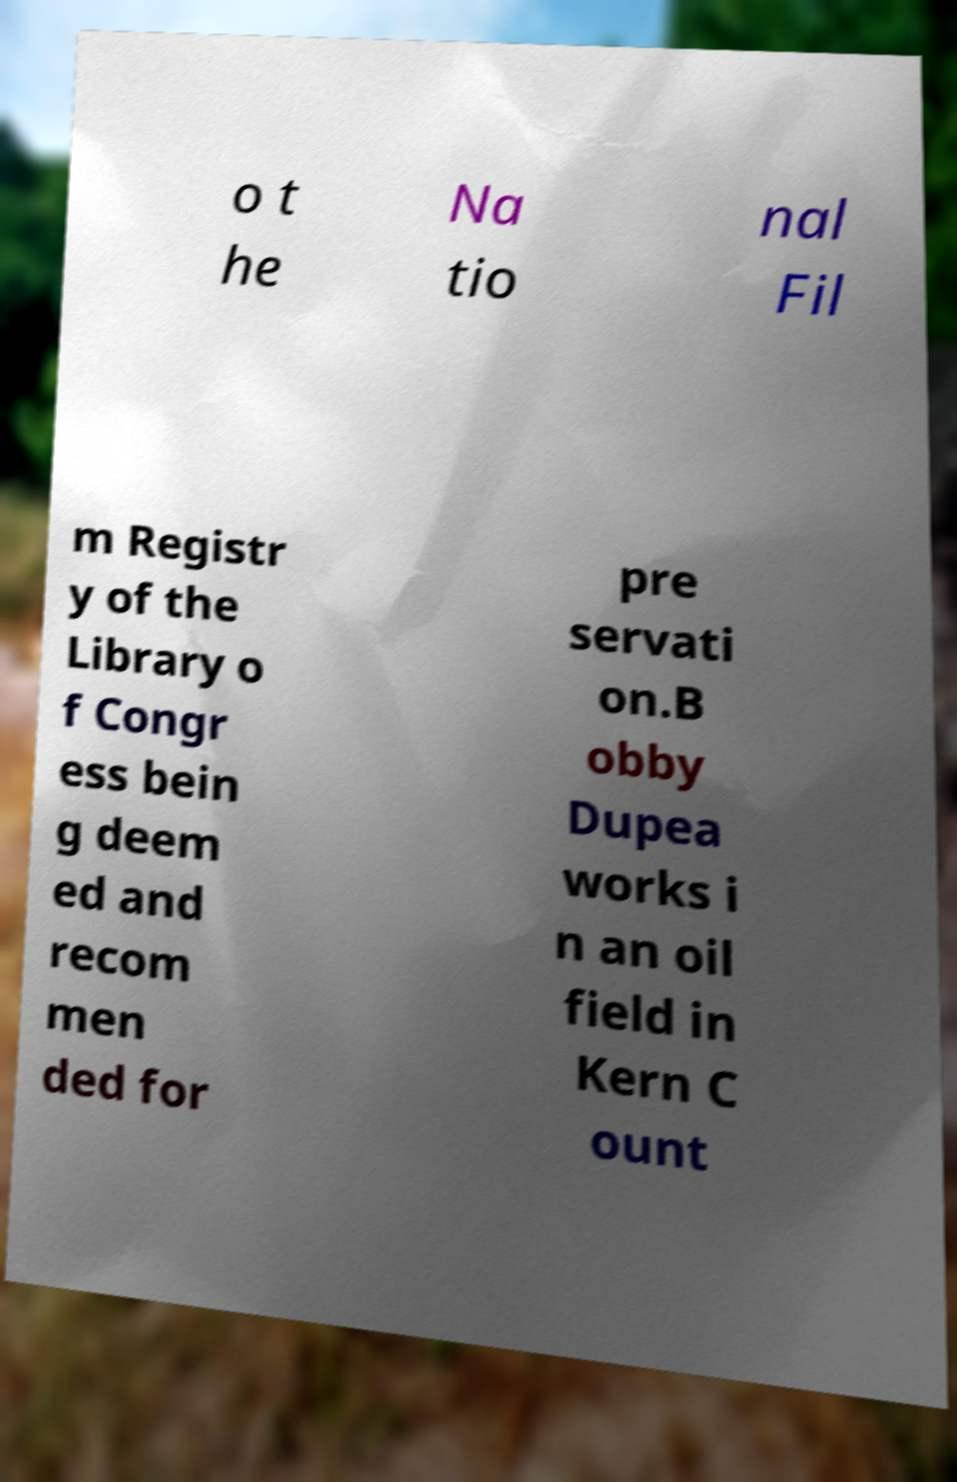Can you accurately transcribe the text from the provided image for me? o t he Na tio nal Fil m Registr y of the Library o f Congr ess bein g deem ed and recom men ded for pre servati on.B obby Dupea works i n an oil field in Kern C ount 